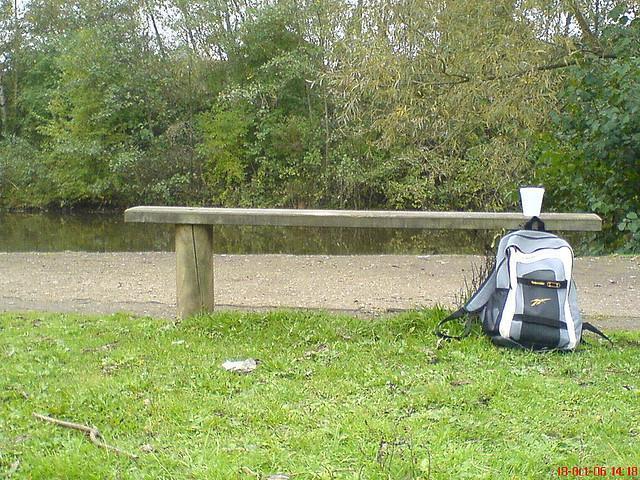How many backpacks are in the photo?
Give a very brief answer. 1. 